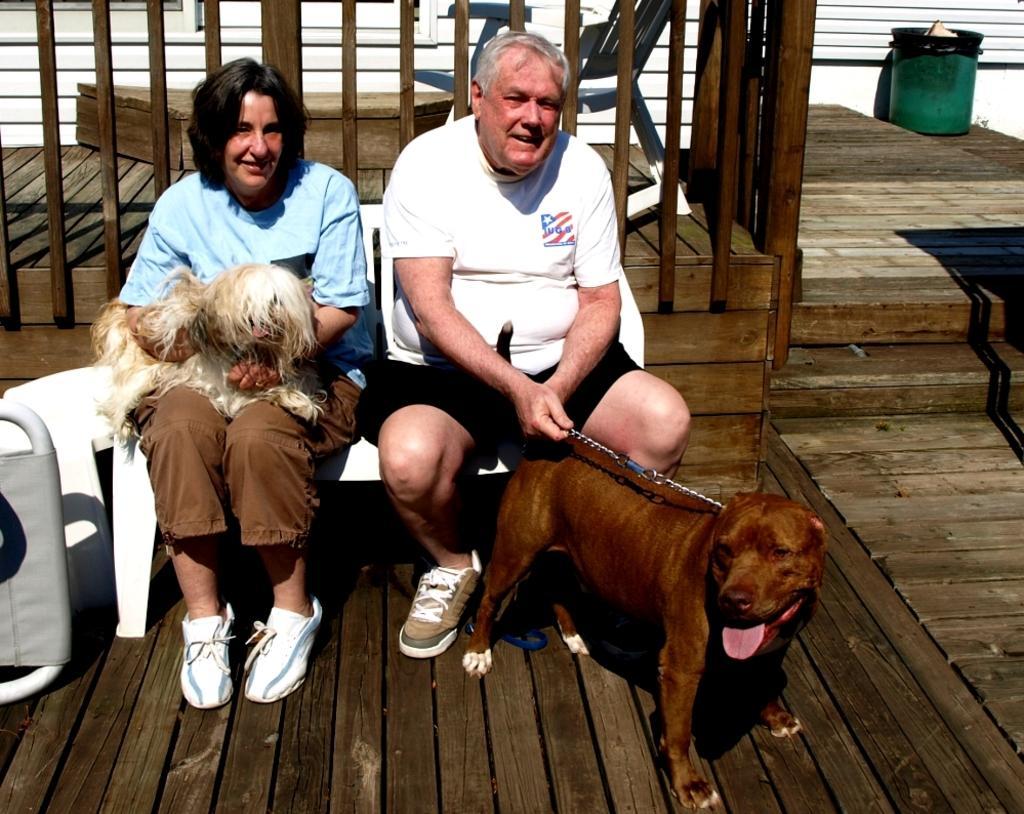Could you give a brief overview of what you see in this image? There are two members sitting in the chairs. One is woman and the other is a man. Both of them were holding dogs in their hands. In the background there is a railing and a bin here. 